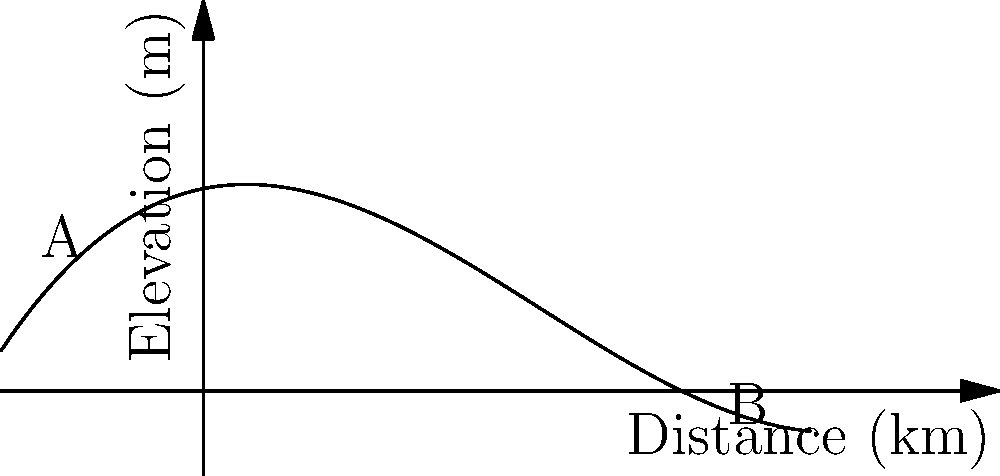A popular mountain road segment for cyclists in the Los Angeles area is represented by the curve shown in the graph. The x-axis represents the horizontal distance traveled, and the y-axis represents the elevation. If the curvature $\kappa$ at any point is given by the formula $\kappa = \frac{|f''(x)|}{(1+(f'(x))^2)^{3/2}}$, where $f(x) = 0.1x^3 - 0.5x^2 + 0.2x + 1$, calculate the maximum curvature along this road segment between points A and B. To find the maximum curvature, we need to follow these steps:

1) First, calculate $f'(x)$ and $f''(x)$:
   $f'(x) = 0.3x^2 - x + 0.2$
   $f''(x) = 0.6x - 1$

2) Substitute these into the curvature formula:
   $\kappa = \frac{|0.6x - 1|}{(1+(0.3x^2 - x + 0.2)^2)^{3/2}}$

3) To find the maximum curvature, we need to find where the derivative of $\kappa$ with respect to $x$ is zero. However, this leads to a complex equation that's difficult to solve analytically.

4) Instead, we can use a numerical approach. We'll calculate the curvature at many points between A and B and find the maximum value.

5) Points A and B correspond to $x = -0.5$ and $x = 2.5$ respectively.

6) Calculating curvature at several points:
   At $x = -0.5$: $\kappa \approx 0.3619$
   At $x = 0$: $\kappa = 1$
   At $x = 0.5$: $\kappa \approx 0.7246$
   At $x = 1$: $\kappa \approx 0.3077$
   At $x = 1.5$: $\kappa \approx 0.1202$
   At $x = 2$: $\kappa \approx 0.0571$
   At $x = 2.5$: $\kappa \approx 0.0393$

7) The maximum curvature occurs at $x = 0$, where $\kappa = 1$.
Answer: 1 